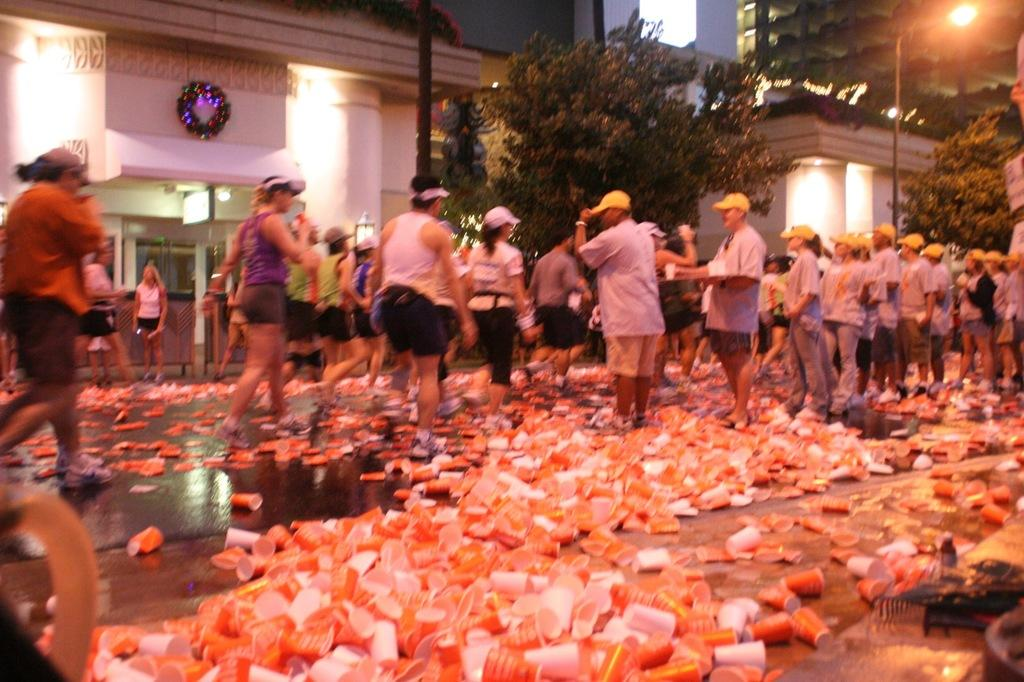How many people are in the group visible in the image? There is a group of people in the image, but the exact number is not specified. What type of headwear can be seen on some of the people in the group? Some people in the group are wearing caps. What objects are on the road in the image? There are cups on the road in the image. What can be seen in the background of the image? There are buildings, trees, poles, and lights in the background of the image. Can you tell me how many deer are visible in the image? There are no deer present in the image. What type of stamp can be seen on the people's clothing in the image? There is no stamp visible on the people's clothing in the image. 